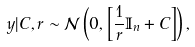Convert formula to latex. <formula><loc_0><loc_0><loc_500><loc_500>y | C , r \sim \mathcal { N } \left ( 0 , \left [ \frac { 1 } { r } \mathbb { I } _ { n } + C \right ] \right ) ,</formula> 